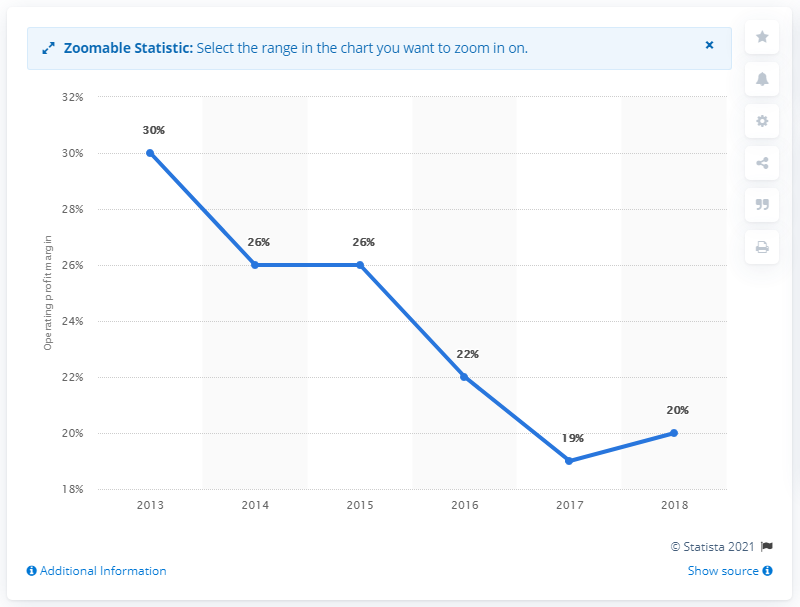Point out several critical features in this image. The overall operating profit margin across all years has a mode that is greater than the median. The profitability of a company or a sector can be determined by its operating profit margin. The trough data value is 19... 